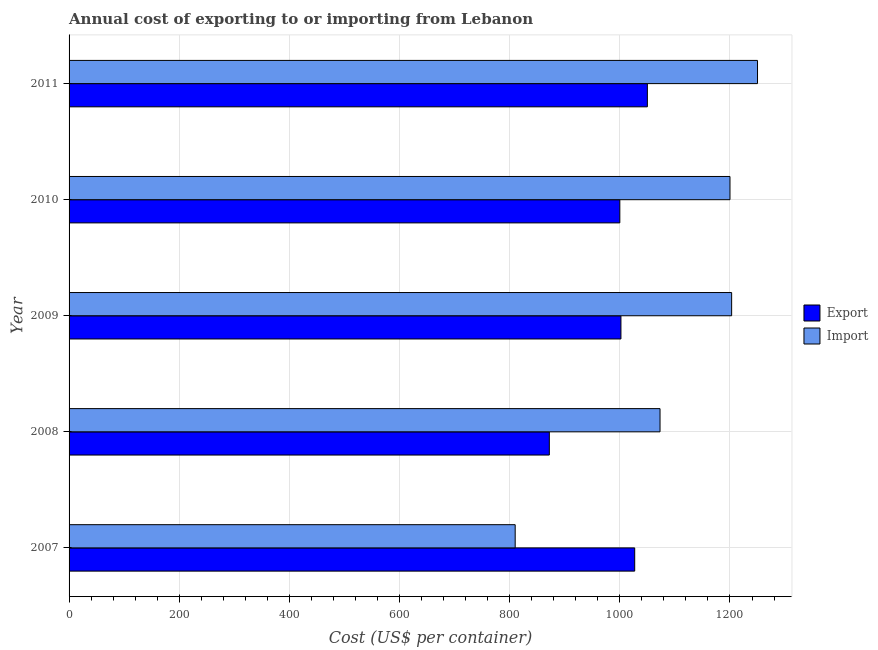How many different coloured bars are there?
Make the answer very short. 2. How many groups of bars are there?
Your answer should be very brief. 5. Are the number of bars on each tick of the Y-axis equal?
Keep it short and to the point. Yes. What is the label of the 4th group of bars from the top?
Your response must be concise. 2008. What is the import cost in 2008?
Your response must be concise. 1073. Across all years, what is the maximum import cost?
Offer a very short reply. 1250. Across all years, what is the minimum export cost?
Offer a very short reply. 872. In which year was the export cost maximum?
Your response must be concise. 2011. What is the total import cost in the graph?
Give a very brief answer. 5536. What is the difference between the import cost in 2008 and that in 2011?
Ensure brevity in your answer.  -177. What is the difference between the export cost in 2010 and the import cost in 2007?
Your answer should be very brief. 190. What is the average import cost per year?
Provide a succinct answer. 1107.2. In the year 2007, what is the difference between the export cost and import cost?
Your answer should be very brief. 217. What is the ratio of the import cost in 2009 to that in 2010?
Provide a short and direct response. 1. Is the difference between the import cost in 2007 and 2011 greater than the difference between the export cost in 2007 and 2011?
Offer a terse response. No. What is the difference between the highest and the lowest import cost?
Your response must be concise. 440. In how many years, is the export cost greater than the average export cost taken over all years?
Give a very brief answer. 4. What does the 2nd bar from the top in 2009 represents?
Offer a terse response. Export. What does the 2nd bar from the bottom in 2007 represents?
Make the answer very short. Import. What is the difference between two consecutive major ticks on the X-axis?
Give a very brief answer. 200. Are the values on the major ticks of X-axis written in scientific E-notation?
Provide a short and direct response. No. Where does the legend appear in the graph?
Make the answer very short. Center right. How many legend labels are there?
Keep it short and to the point. 2. How are the legend labels stacked?
Offer a terse response. Vertical. What is the title of the graph?
Offer a terse response. Annual cost of exporting to or importing from Lebanon. Does "Personal remittances" appear as one of the legend labels in the graph?
Your answer should be compact. No. What is the label or title of the X-axis?
Your response must be concise. Cost (US$ per container). What is the Cost (US$ per container) of Export in 2007?
Provide a succinct answer. 1027. What is the Cost (US$ per container) of Import in 2007?
Your answer should be very brief. 810. What is the Cost (US$ per container) in Export in 2008?
Give a very brief answer. 872. What is the Cost (US$ per container) in Import in 2008?
Your answer should be very brief. 1073. What is the Cost (US$ per container) of Export in 2009?
Offer a very short reply. 1002. What is the Cost (US$ per container) in Import in 2009?
Provide a short and direct response. 1203. What is the Cost (US$ per container) in Import in 2010?
Your answer should be very brief. 1200. What is the Cost (US$ per container) of Export in 2011?
Keep it short and to the point. 1050. What is the Cost (US$ per container) in Import in 2011?
Provide a short and direct response. 1250. Across all years, what is the maximum Cost (US$ per container) of Export?
Keep it short and to the point. 1050. Across all years, what is the maximum Cost (US$ per container) of Import?
Ensure brevity in your answer.  1250. Across all years, what is the minimum Cost (US$ per container) in Export?
Offer a terse response. 872. Across all years, what is the minimum Cost (US$ per container) in Import?
Offer a very short reply. 810. What is the total Cost (US$ per container) of Export in the graph?
Provide a short and direct response. 4951. What is the total Cost (US$ per container) in Import in the graph?
Keep it short and to the point. 5536. What is the difference between the Cost (US$ per container) of Export in 2007 and that in 2008?
Your answer should be very brief. 155. What is the difference between the Cost (US$ per container) of Import in 2007 and that in 2008?
Keep it short and to the point. -263. What is the difference between the Cost (US$ per container) of Export in 2007 and that in 2009?
Your answer should be very brief. 25. What is the difference between the Cost (US$ per container) of Import in 2007 and that in 2009?
Your answer should be very brief. -393. What is the difference between the Cost (US$ per container) in Import in 2007 and that in 2010?
Provide a succinct answer. -390. What is the difference between the Cost (US$ per container) of Import in 2007 and that in 2011?
Provide a short and direct response. -440. What is the difference between the Cost (US$ per container) in Export in 2008 and that in 2009?
Make the answer very short. -130. What is the difference between the Cost (US$ per container) of Import in 2008 and that in 2009?
Make the answer very short. -130. What is the difference between the Cost (US$ per container) in Export in 2008 and that in 2010?
Your answer should be very brief. -128. What is the difference between the Cost (US$ per container) in Import in 2008 and that in 2010?
Your response must be concise. -127. What is the difference between the Cost (US$ per container) of Export in 2008 and that in 2011?
Make the answer very short. -178. What is the difference between the Cost (US$ per container) in Import in 2008 and that in 2011?
Your response must be concise. -177. What is the difference between the Cost (US$ per container) in Export in 2009 and that in 2010?
Ensure brevity in your answer.  2. What is the difference between the Cost (US$ per container) of Export in 2009 and that in 2011?
Keep it short and to the point. -48. What is the difference between the Cost (US$ per container) of Import in 2009 and that in 2011?
Offer a terse response. -47. What is the difference between the Cost (US$ per container) in Export in 2007 and the Cost (US$ per container) in Import in 2008?
Your response must be concise. -46. What is the difference between the Cost (US$ per container) in Export in 2007 and the Cost (US$ per container) in Import in 2009?
Ensure brevity in your answer.  -176. What is the difference between the Cost (US$ per container) in Export in 2007 and the Cost (US$ per container) in Import in 2010?
Provide a short and direct response. -173. What is the difference between the Cost (US$ per container) of Export in 2007 and the Cost (US$ per container) of Import in 2011?
Offer a very short reply. -223. What is the difference between the Cost (US$ per container) in Export in 2008 and the Cost (US$ per container) in Import in 2009?
Your response must be concise. -331. What is the difference between the Cost (US$ per container) of Export in 2008 and the Cost (US$ per container) of Import in 2010?
Make the answer very short. -328. What is the difference between the Cost (US$ per container) of Export in 2008 and the Cost (US$ per container) of Import in 2011?
Offer a terse response. -378. What is the difference between the Cost (US$ per container) in Export in 2009 and the Cost (US$ per container) in Import in 2010?
Provide a short and direct response. -198. What is the difference between the Cost (US$ per container) in Export in 2009 and the Cost (US$ per container) in Import in 2011?
Your response must be concise. -248. What is the difference between the Cost (US$ per container) of Export in 2010 and the Cost (US$ per container) of Import in 2011?
Provide a succinct answer. -250. What is the average Cost (US$ per container) of Export per year?
Give a very brief answer. 990.2. What is the average Cost (US$ per container) in Import per year?
Offer a very short reply. 1107.2. In the year 2007, what is the difference between the Cost (US$ per container) of Export and Cost (US$ per container) of Import?
Ensure brevity in your answer.  217. In the year 2008, what is the difference between the Cost (US$ per container) in Export and Cost (US$ per container) in Import?
Offer a terse response. -201. In the year 2009, what is the difference between the Cost (US$ per container) in Export and Cost (US$ per container) in Import?
Provide a short and direct response. -201. In the year 2010, what is the difference between the Cost (US$ per container) in Export and Cost (US$ per container) in Import?
Offer a very short reply. -200. In the year 2011, what is the difference between the Cost (US$ per container) in Export and Cost (US$ per container) in Import?
Make the answer very short. -200. What is the ratio of the Cost (US$ per container) in Export in 2007 to that in 2008?
Offer a very short reply. 1.18. What is the ratio of the Cost (US$ per container) of Import in 2007 to that in 2008?
Your response must be concise. 0.75. What is the ratio of the Cost (US$ per container) of Import in 2007 to that in 2009?
Offer a terse response. 0.67. What is the ratio of the Cost (US$ per container) in Import in 2007 to that in 2010?
Provide a succinct answer. 0.68. What is the ratio of the Cost (US$ per container) of Export in 2007 to that in 2011?
Your response must be concise. 0.98. What is the ratio of the Cost (US$ per container) in Import in 2007 to that in 2011?
Make the answer very short. 0.65. What is the ratio of the Cost (US$ per container) of Export in 2008 to that in 2009?
Your response must be concise. 0.87. What is the ratio of the Cost (US$ per container) in Import in 2008 to that in 2009?
Ensure brevity in your answer.  0.89. What is the ratio of the Cost (US$ per container) in Export in 2008 to that in 2010?
Ensure brevity in your answer.  0.87. What is the ratio of the Cost (US$ per container) in Import in 2008 to that in 2010?
Provide a succinct answer. 0.89. What is the ratio of the Cost (US$ per container) of Export in 2008 to that in 2011?
Give a very brief answer. 0.83. What is the ratio of the Cost (US$ per container) in Import in 2008 to that in 2011?
Your response must be concise. 0.86. What is the ratio of the Cost (US$ per container) in Export in 2009 to that in 2010?
Your response must be concise. 1. What is the ratio of the Cost (US$ per container) in Import in 2009 to that in 2010?
Ensure brevity in your answer.  1. What is the ratio of the Cost (US$ per container) of Export in 2009 to that in 2011?
Ensure brevity in your answer.  0.95. What is the ratio of the Cost (US$ per container) in Import in 2009 to that in 2011?
Your response must be concise. 0.96. What is the ratio of the Cost (US$ per container) of Import in 2010 to that in 2011?
Ensure brevity in your answer.  0.96. What is the difference between the highest and the second highest Cost (US$ per container) in Export?
Make the answer very short. 23. What is the difference between the highest and the second highest Cost (US$ per container) of Import?
Give a very brief answer. 47. What is the difference between the highest and the lowest Cost (US$ per container) in Export?
Make the answer very short. 178. What is the difference between the highest and the lowest Cost (US$ per container) of Import?
Provide a succinct answer. 440. 